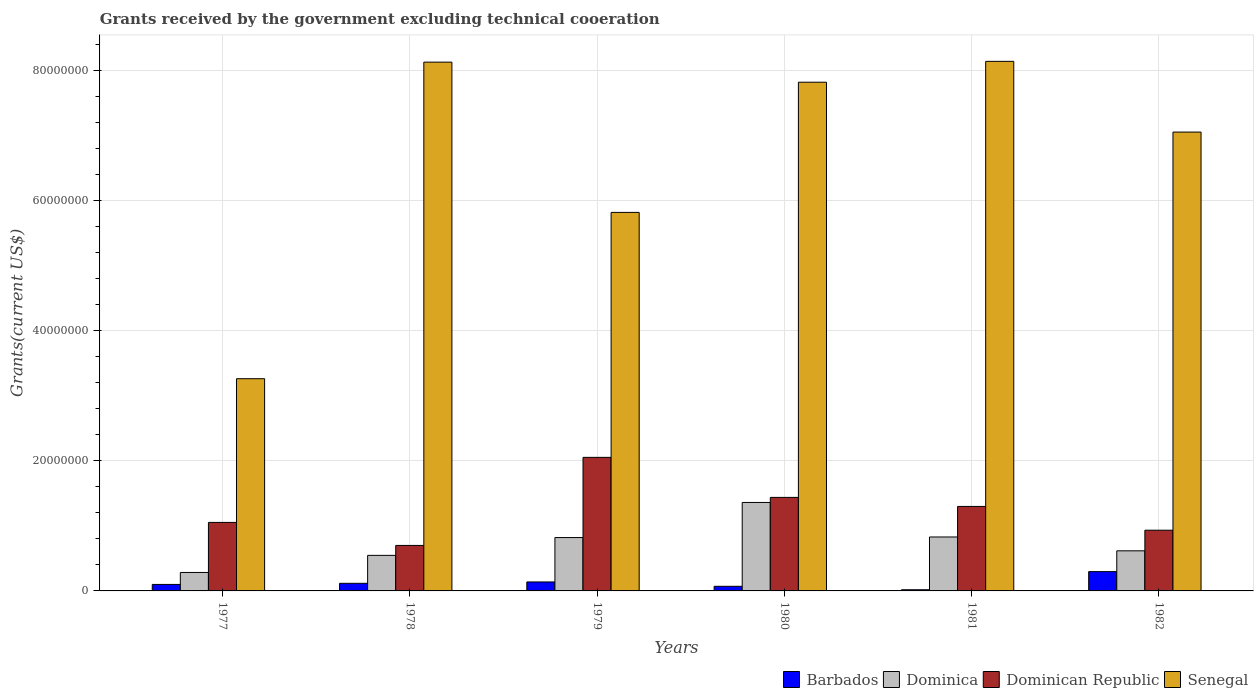How many different coloured bars are there?
Provide a succinct answer. 4. How many groups of bars are there?
Provide a succinct answer. 6. How many bars are there on the 4th tick from the left?
Ensure brevity in your answer.  4. How many bars are there on the 3rd tick from the right?
Give a very brief answer. 4. In how many cases, is the number of bars for a given year not equal to the number of legend labels?
Your response must be concise. 0. What is the total grants received by the government in Dominica in 1980?
Provide a succinct answer. 1.36e+07. Across all years, what is the maximum total grants received by the government in Dominican Republic?
Give a very brief answer. 2.06e+07. In which year was the total grants received by the government in Barbados maximum?
Give a very brief answer. 1982. In which year was the total grants received by the government in Barbados minimum?
Your answer should be compact. 1981. What is the total total grants received by the government in Dominican Republic in the graph?
Your response must be concise. 7.48e+07. What is the difference between the total grants received by the government in Senegal in 1979 and that in 1981?
Offer a terse response. -2.32e+07. What is the difference between the total grants received by the government in Senegal in 1981 and the total grants received by the government in Dominica in 1980?
Provide a succinct answer. 6.79e+07. What is the average total grants received by the government in Senegal per year?
Offer a terse response. 6.71e+07. In the year 1979, what is the difference between the total grants received by the government in Barbados and total grants received by the government in Senegal?
Provide a short and direct response. -5.69e+07. In how many years, is the total grants received by the government in Dominica greater than 20000000 US$?
Provide a short and direct response. 0. What is the ratio of the total grants received by the government in Dominican Republic in 1978 to that in 1981?
Offer a very short reply. 0.54. Is the difference between the total grants received by the government in Barbados in 1977 and 1981 greater than the difference between the total grants received by the government in Senegal in 1977 and 1981?
Keep it short and to the point. Yes. What is the difference between the highest and the lowest total grants received by the government in Senegal?
Give a very brief answer. 4.88e+07. Is it the case that in every year, the sum of the total grants received by the government in Dominica and total grants received by the government in Senegal is greater than the sum of total grants received by the government in Dominican Republic and total grants received by the government in Barbados?
Your answer should be compact. No. What does the 4th bar from the left in 1978 represents?
Give a very brief answer. Senegal. What does the 1st bar from the right in 1978 represents?
Your answer should be compact. Senegal. Is it the case that in every year, the sum of the total grants received by the government in Senegal and total grants received by the government in Dominican Republic is greater than the total grants received by the government in Dominica?
Keep it short and to the point. Yes. What is the difference between two consecutive major ticks on the Y-axis?
Ensure brevity in your answer.  2.00e+07. Are the values on the major ticks of Y-axis written in scientific E-notation?
Ensure brevity in your answer.  No. How many legend labels are there?
Ensure brevity in your answer.  4. What is the title of the graph?
Ensure brevity in your answer.  Grants received by the government excluding technical cooeration. What is the label or title of the X-axis?
Provide a succinct answer. Years. What is the label or title of the Y-axis?
Offer a terse response. Grants(current US$). What is the Grants(current US$) in Barbados in 1977?
Your response must be concise. 1.00e+06. What is the Grants(current US$) in Dominica in 1977?
Make the answer very short. 2.84e+06. What is the Grants(current US$) of Dominican Republic in 1977?
Give a very brief answer. 1.05e+07. What is the Grants(current US$) of Senegal in 1977?
Ensure brevity in your answer.  3.26e+07. What is the Grants(current US$) in Barbados in 1978?
Offer a very short reply. 1.17e+06. What is the Grants(current US$) in Dominica in 1978?
Offer a terse response. 5.47e+06. What is the Grants(current US$) in Senegal in 1978?
Keep it short and to the point. 8.14e+07. What is the Grants(current US$) in Barbados in 1979?
Keep it short and to the point. 1.38e+06. What is the Grants(current US$) in Dominica in 1979?
Offer a terse response. 8.21e+06. What is the Grants(current US$) in Dominican Republic in 1979?
Ensure brevity in your answer.  2.06e+07. What is the Grants(current US$) of Senegal in 1979?
Provide a short and direct response. 5.82e+07. What is the Grants(current US$) in Barbados in 1980?
Offer a very short reply. 7.10e+05. What is the Grants(current US$) in Dominica in 1980?
Your response must be concise. 1.36e+07. What is the Grants(current US$) in Dominican Republic in 1980?
Your answer should be compact. 1.44e+07. What is the Grants(current US$) of Senegal in 1980?
Offer a terse response. 7.83e+07. What is the Grants(current US$) in Barbados in 1981?
Offer a very short reply. 1.80e+05. What is the Grants(current US$) of Dominica in 1981?
Give a very brief answer. 8.30e+06. What is the Grants(current US$) in Dominican Republic in 1981?
Give a very brief answer. 1.30e+07. What is the Grants(current US$) of Senegal in 1981?
Keep it short and to the point. 8.15e+07. What is the Grants(current US$) in Barbados in 1982?
Ensure brevity in your answer.  2.97e+06. What is the Grants(current US$) in Dominica in 1982?
Your answer should be compact. 6.17e+06. What is the Grants(current US$) in Dominican Republic in 1982?
Offer a terse response. 9.34e+06. What is the Grants(current US$) of Senegal in 1982?
Your answer should be compact. 7.06e+07. Across all years, what is the maximum Grants(current US$) of Barbados?
Offer a very short reply. 2.97e+06. Across all years, what is the maximum Grants(current US$) of Dominica?
Your response must be concise. 1.36e+07. Across all years, what is the maximum Grants(current US$) in Dominican Republic?
Make the answer very short. 2.06e+07. Across all years, what is the maximum Grants(current US$) in Senegal?
Provide a short and direct response. 8.15e+07. Across all years, what is the minimum Grants(current US$) of Barbados?
Provide a short and direct response. 1.80e+05. Across all years, what is the minimum Grants(current US$) of Dominica?
Your answer should be compact. 2.84e+06. Across all years, what is the minimum Grants(current US$) of Senegal?
Give a very brief answer. 3.26e+07. What is the total Grants(current US$) in Barbados in the graph?
Provide a succinct answer. 7.41e+06. What is the total Grants(current US$) of Dominica in the graph?
Keep it short and to the point. 4.46e+07. What is the total Grants(current US$) of Dominican Republic in the graph?
Provide a succinct answer. 7.48e+07. What is the total Grants(current US$) of Senegal in the graph?
Your response must be concise. 4.03e+08. What is the difference between the Grants(current US$) in Barbados in 1977 and that in 1978?
Keep it short and to the point. -1.70e+05. What is the difference between the Grants(current US$) in Dominica in 1977 and that in 1978?
Your answer should be very brief. -2.63e+06. What is the difference between the Grants(current US$) in Dominican Republic in 1977 and that in 1978?
Give a very brief answer. 3.54e+06. What is the difference between the Grants(current US$) of Senegal in 1977 and that in 1978?
Your response must be concise. -4.87e+07. What is the difference between the Grants(current US$) of Barbados in 1977 and that in 1979?
Give a very brief answer. -3.80e+05. What is the difference between the Grants(current US$) of Dominica in 1977 and that in 1979?
Provide a succinct answer. -5.37e+06. What is the difference between the Grants(current US$) of Dominican Republic in 1977 and that in 1979?
Give a very brief answer. -1.00e+07. What is the difference between the Grants(current US$) in Senegal in 1977 and that in 1979?
Your response must be concise. -2.56e+07. What is the difference between the Grants(current US$) in Dominica in 1977 and that in 1980?
Provide a succinct answer. -1.08e+07. What is the difference between the Grants(current US$) in Dominican Republic in 1977 and that in 1980?
Your answer should be compact. -3.85e+06. What is the difference between the Grants(current US$) in Senegal in 1977 and that in 1980?
Make the answer very short. -4.56e+07. What is the difference between the Grants(current US$) of Barbados in 1977 and that in 1981?
Provide a succinct answer. 8.20e+05. What is the difference between the Grants(current US$) in Dominica in 1977 and that in 1981?
Provide a succinct answer. -5.46e+06. What is the difference between the Grants(current US$) of Dominican Republic in 1977 and that in 1981?
Ensure brevity in your answer.  -2.46e+06. What is the difference between the Grants(current US$) in Senegal in 1977 and that in 1981?
Ensure brevity in your answer.  -4.88e+07. What is the difference between the Grants(current US$) in Barbados in 1977 and that in 1982?
Offer a very short reply. -1.97e+06. What is the difference between the Grants(current US$) in Dominica in 1977 and that in 1982?
Your response must be concise. -3.33e+06. What is the difference between the Grants(current US$) of Dominican Republic in 1977 and that in 1982?
Your answer should be very brief. 1.20e+06. What is the difference between the Grants(current US$) of Senegal in 1977 and that in 1982?
Offer a terse response. -3.80e+07. What is the difference between the Grants(current US$) of Dominica in 1978 and that in 1979?
Give a very brief answer. -2.74e+06. What is the difference between the Grants(current US$) in Dominican Republic in 1978 and that in 1979?
Ensure brevity in your answer.  -1.36e+07. What is the difference between the Grants(current US$) in Senegal in 1978 and that in 1979?
Provide a succinct answer. 2.31e+07. What is the difference between the Grants(current US$) of Dominica in 1978 and that in 1980?
Provide a succinct answer. -8.14e+06. What is the difference between the Grants(current US$) of Dominican Republic in 1978 and that in 1980?
Your answer should be very brief. -7.39e+06. What is the difference between the Grants(current US$) of Senegal in 1978 and that in 1980?
Make the answer very short. 3.09e+06. What is the difference between the Grants(current US$) of Barbados in 1978 and that in 1981?
Ensure brevity in your answer.  9.90e+05. What is the difference between the Grants(current US$) of Dominica in 1978 and that in 1981?
Keep it short and to the point. -2.83e+06. What is the difference between the Grants(current US$) in Dominican Republic in 1978 and that in 1981?
Provide a succinct answer. -6.00e+06. What is the difference between the Grants(current US$) of Barbados in 1978 and that in 1982?
Keep it short and to the point. -1.80e+06. What is the difference between the Grants(current US$) in Dominica in 1978 and that in 1982?
Your response must be concise. -7.00e+05. What is the difference between the Grants(current US$) of Dominican Republic in 1978 and that in 1982?
Keep it short and to the point. -2.34e+06. What is the difference between the Grants(current US$) of Senegal in 1978 and that in 1982?
Provide a succinct answer. 1.08e+07. What is the difference between the Grants(current US$) of Barbados in 1979 and that in 1980?
Make the answer very short. 6.70e+05. What is the difference between the Grants(current US$) of Dominica in 1979 and that in 1980?
Offer a terse response. -5.40e+06. What is the difference between the Grants(current US$) of Dominican Republic in 1979 and that in 1980?
Make the answer very short. 6.16e+06. What is the difference between the Grants(current US$) of Senegal in 1979 and that in 1980?
Offer a very short reply. -2.00e+07. What is the difference between the Grants(current US$) of Barbados in 1979 and that in 1981?
Offer a terse response. 1.20e+06. What is the difference between the Grants(current US$) in Dominican Republic in 1979 and that in 1981?
Make the answer very short. 7.55e+06. What is the difference between the Grants(current US$) in Senegal in 1979 and that in 1981?
Ensure brevity in your answer.  -2.32e+07. What is the difference between the Grants(current US$) in Barbados in 1979 and that in 1982?
Give a very brief answer. -1.59e+06. What is the difference between the Grants(current US$) of Dominica in 1979 and that in 1982?
Give a very brief answer. 2.04e+06. What is the difference between the Grants(current US$) of Dominican Republic in 1979 and that in 1982?
Your answer should be very brief. 1.12e+07. What is the difference between the Grants(current US$) of Senegal in 1979 and that in 1982?
Provide a succinct answer. -1.24e+07. What is the difference between the Grants(current US$) in Barbados in 1980 and that in 1981?
Your answer should be compact. 5.30e+05. What is the difference between the Grants(current US$) in Dominica in 1980 and that in 1981?
Offer a very short reply. 5.31e+06. What is the difference between the Grants(current US$) in Dominican Republic in 1980 and that in 1981?
Make the answer very short. 1.39e+06. What is the difference between the Grants(current US$) of Senegal in 1980 and that in 1981?
Make the answer very short. -3.21e+06. What is the difference between the Grants(current US$) of Barbados in 1980 and that in 1982?
Your response must be concise. -2.26e+06. What is the difference between the Grants(current US$) in Dominica in 1980 and that in 1982?
Provide a short and direct response. 7.44e+06. What is the difference between the Grants(current US$) of Dominican Republic in 1980 and that in 1982?
Give a very brief answer. 5.05e+06. What is the difference between the Grants(current US$) of Senegal in 1980 and that in 1982?
Offer a very short reply. 7.67e+06. What is the difference between the Grants(current US$) of Barbados in 1981 and that in 1982?
Provide a short and direct response. -2.79e+06. What is the difference between the Grants(current US$) in Dominica in 1981 and that in 1982?
Your answer should be compact. 2.13e+06. What is the difference between the Grants(current US$) of Dominican Republic in 1981 and that in 1982?
Your answer should be compact. 3.66e+06. What is the difference between the Grants(current US$) of Senegal in 1981 and that in 1982?
Give a very brief answer. 1.09e+07. What is the difference between the Grants(current US$) in Barbados in 1977 and the Grants(current US$) in Dominica in 1978?
Keep it short and to the point. -4.47e+06. What is the difference between the Grants(current US$) in Barbados in 1977 and the Grants(current US$) in Dominican Republic in 1978?
Give a very brief answer. -6.00e+06. What is the difference between the Grants(current US$) in Barbados in 1977 and the Grants(current US$) in Senegal in 1978?
Offer a very short reply. -8.04e+07. What is the difference between the Grants(current US$) in Dominica in 1977 and the Grants(current US$) in Dominican Republic in 1978?
Your response must be concise. -4.16e+06. What is the difference between the Grants(current US$) in Dominica in 1977 and the Grants(current US$) in Senegal in 1978?
Ensure brevity in your answer.  -7.85e+07. What is the difference between the Grants(current US$) of Dominican Republic in 1977 and the Grants(current US$) of Senegal in 1978?
Your answer should be very brief. -7.08e+07. What is the difference between the Grants(current US$) in Barbados in 1977 and the Grants(current US$) in Dominica in 1979?
Ensure brevity in your answer.  -7.21e+06. What is the difference between the Grants(current US$) in Barbados in 1977 and the Grants(current US$) in Dominican Republic in 1979?
Make the answer very short. -1.96e+07. What is the difference between the Grants(current US$) in Barbados in 1977 and the Grants(current US$) in Senegal in 1979?
Ensure brevity in your answer.  -5.72e+07. What is the difference between the Grants(current US$) of Dominica in 1977 and the Grants(current US$) of Dominican Republic in 1979?
Offer a very short reply. -1.77e+07. What is the difference between the Grants(current US$) in Dominica in 1977 and the Grants(current US$) in Senegal in 1979?
Ensure brevity in your answer.  -5.54e+07. What is the difference between the Grants(current US$) of Dominican Republic in 1977 and the Grants(current US$) of Senegal in 1979?
Your answer should be compact. -4.77e+07. What is the difference between the Grants(current US$) in Barbados in 1977 and the Grants(current US$) in Dominica in 1980?
Your answer should be compact. -1.26e+07. What is the difference between the Grants(current US$) in Barbados in 1977 and the Grants(current US$) in Dominican Republic in 1980?
Provide a short and direct response. -1.34e+07. What is the difference between the Grants(current US$) of Barbados in 1977 and the Grants(current US$) of Senegal in 1980?
Your response must be concise. -7.73e+07. What is the difference between the Grants(current US$) of Dominica in 1977 and the Grants(current US$) of Dominican Republic in 1980?
Provide a succinct answer. -1.16e+07. What is the difference between the Grants(current US$) of Dominica in 1977 and the Grants(current US$) of Senegal in 1980?
Provide a short and direct response. -7.54e+07. What is the difference between the Grants(current US$) in Dominican Republic in 1977 and the Grants(current US$) in Senegal in 1980?
Give a very brief answer. -6.77e+07. What is the difference between the Grants(current US$) of Barbados in 1977 and the Grants(current US$) of Dominica in 1981?
Give a very brief answer. -7.30e+06. What is the difference between the Grants(current US$) in Barbados in 1977 and the Grants(current US$) in Dominican Republic in 1981?
Give a very brief answer. -1.20e+07. What is the difference between the Grants(current US$) in Barbados in 1977 and the Grants(current US$) in Senegal in 1981?
Offer a terse response. -8.05e+07. What is the difference between the Grants(current US$) of Dominica in 1977 and the Grants(current US$) of Dominican Republic in 1981?
Your response must be concise. -1.02e+07. What is the difference between the Grants(current US$) in Dominica in 1977 and the Grants(current US$) in Senegal in 1981?
Make the answer very short. -7.86e+07. What is the difference between the Grants(current US$) in Dominican Republic in 1977 and the Grants(current US$) in Senegal in 1981?
Offer a terse response. -7.09e+07. What is the difference between the Grants(current US$) in Barbados in 1977 and the Grants(current US$) in Dominica in 1982?
Your answer should be very brief. -5.17e+06. What is the difference between the Grants(current US$) of Barbados in 1977 and the Grants(current US$) of Dominican Republic in 1982?
Offer a terse response. -8.34e+06. What is the difference between the Grants(current US$) of Barbados in 1977 and the Grants(current US$) of Senegal in 1982?
Provide a short and direct response. -6.96e+07. What is the difference between the Grants(current US$) of Dominica in 1977 and the Grants(current US$) of Dominican Republic in 1982?
Provide a short and direct response. -6.50e+06. What is the difference between the Grants(current US$) in Dominica in 1977 and the Grants(current US$) in Senegal in 1982?
Keep it short and to the point. -6.78e+07. What is the difference between the Grants(current US$) of Dominican Republic in 1977 and the Grants(current US$) of Senegal in 1982?
Give a very brief answer. -6.01e+07. What is the difference between the Grants(current US$) in Barbados in 1978 and the Grants(current US$) in Dominica in 1979?
Offer a very short reply. -7.04e+06. What is the difference between the Grants(current US$) of Barbados in 1978 and the Grants(current US$) of Dominican Republic in 1979?
Give a very brief answer. -1.94e+07. What is the difference between the Grants(current US$) in Barbados in 1978 and the Grants(current US$) in Senegal in 1979?
Your response must be concise. -5.71e+07. What is the difference between the Grants(current US$) of Dominica in 1978 and the Grants(current US$) of Dominican Republic in 1979?
Your response must be concise. -1.51e+07. What is the difference between the Grants(current US$) of Dominica in 1978 and the Grants(current US$) of Senegal in 1979?
Ensure brevity in your answer.  -5.28e+07. What is the difference between the Grants(current US$) of Dominican Republic in 1978 and the Grants(current US$) of Senegal in 1979?
Provide a short and direct response. -5.12e+07. What is the difference between the Grants(current US$) of Barbados in 1978 and the Grants(current US$) of Dominica in 1980?
Ensure brevity in your answer.  -1.24e+07. What is the difference between the Grants(current US$) of Barbados in 1978 and the Grants(current US$) of Dominican Republic in 1980?
Offer a very short reply. -1.32e+07. What is the difference between the Grants(current US$) in Barbados in 1978 and the Grants(current US$) in Senegal in 1980?
Make the answer very short. -7.71e+07. What is the difference between the Grants(current US$) of Dominica in 1978 and the Grants(current US$) of Dominican Republic in 1980?
Provide a short and direct response. -8.92e+06. What is the difference between the Grants(current US$) of Dominica in 1978 and the Grants(current US$) of Senegal in 1980?
Keep it short and to the point. -7.28e+07. What is the difference between the Grants(current US$) of Dominican Republic in 1978 and the Grants(current US$) of Senegal in 1980?
Make the answer very short. -7.13e+07. What is the difference between the Grants(current US$) of Barbados in 1978 and the Grants(current US$) of Dominica in 1981?
Give a very brief answer. -7.13e+06. What is the difference between the Grants(current US$) in Barbados in 1978 and the Grants(current US$) in Dominican Republic in 1981?
Your answer should be compact. -1.18e+07. What is the difference between the Grants(current US$) of Barbados in 1978 and the Grants(current US$) of Senegal in 1981?
Give a very brief answer. -8.03e+07. What is the difference between the Grants(current US$) in Dominica in 1978 and the Grants(current US$) in Dominican Republic in 1981?
Ensure brevity in your answer.  -7.53e+06. What is the difference between the Grants(current US$) of Dominica in 1978 and the Grants(current US$) of Senegal in 1981?
Keep it short and to the point. -7.60e+07. What is the difference between the Grants(current US$) in Dominican Republic in 1978 and the Grants(current US$) in Senegal in 1981?
Your answer should be very brief. -7.45e+07. What is the difference between the Grants(current US$) in Barbados in 1978 and the Grants(current US$) in Dominica in 1982?
Your response must be concise. -5.00e+06. What is the difference between the Grants(current US$) in Barbados in 1978 and the Grants(current US$) in Dominican Republic in 1982?
Provide a succinct answer. -8.17e+06. What is the difference between the Grants(current US$) of Barbados in 1978 and the Grants(current US$) of Senegal in 1982?
Provide a succinct answer. -6.94e+07. What is the difference between the Grants(current US$) of Dominica in 1978 and the Grants(current US$) of Dominican Republic in 1982?
Your answer should be compact. -3.87e+06. What is the difference between the Grants(current US$) in Dominica in 1978 and the Grants(current US$) in Senegal in 1982?
Provide a short and direct response. -6.51e+07. What is the difference between the Grants(current US$) of Dominican Republic in 1978 and the Grants(current US$) of Senegal in 1982?
Make the answer very short. -6.36e+07. What is the difference between the Grants(current US$) in Barbados in 1979 and the Grants(current US$) in Dominica in 1980?
Your response must be concise. -1.22e+07. What is the difference between the Grants(current US$) in Barbados in 1979 and the Grants(current US$) in Dominican Republic in 1980?
Offer a terse response. -1.30e+07. What is the difference between the Grants(current US$) in Barbados in 1979 and the Grants(current US$) in Senegal in 1980?
Offer a very short reply. -7.69e+07. What is the difference between the Grants(current US$) of Dominica in 1979 and the Grants(current US$) of Dominican Republic in 1980?
Offer a terse response. -6.18e+06. What is the difference between the Grants(current US$) in Dominica in 1979 and the Grants(current US$) in Senegal in 1980?
Your answer should be very brief. -7.01e+07. What is the difference between the Grants(current US$) of Dominican Republic in 1979 and the Grants(current US$) of Senegal in 1980?
Offer a very short reply. -5.77e+07. What is the difference between the Grants(current US$) in Barbados in 1979 and the Grants(current US$) in Dominica in 1981?
Your answer should be compact. -6.92e+06. What is the difference between the Grants(current US$) in Barbados in 1979 and the Grants(current US$) in Dominican Republic in 1981?
Keep it short and to the point. -1.16e+07. What is the difference between the Grants(current US$) of Barbados in 1979 and the Grants(current US$) of Senegal in 1981?
Provide a succinct answer. -8.01e+07. What is the difference between the Grants(current US$) of Dominica in 1979 and the Grants(current US$) of Dominican Republic in 1981?
Your answer should be very brief. -4.79e+06. What is the difference between the Grants(current US$) of Dominica in 1979 and the Grants(current US$) of Senegal in 1981?
Make the answer very short. -7.33e+07. What is the difference between the Grants(current US$) in Dominican Republic in 1979 and the Grants(current US$) in Senegal in 1981?
Provide a short and direct response. -6.09e+07. What is the difference between the Grants(current US$) of Barbados in 1979 and the Grants(current US$) of Dominica in 1982?
Offer a terse response. -4.79e+06. What is the difference between the Grants(current US$) in Barbados in 1979 and the Grants(current US$) in Dominican Republic in 1982?
Make the answer very short. -7.96e+06. What is the difference between the Grants(current US$) of Barbados in 1979 and the Grants(current US$) of Senegal in 1982?
Provide a short and direct response. -6.92e+07. What is the difference between the Grants(current US$) of Dominica in 1979 and the Grants(current US$) of Dominican Republic in 1982?
Provide a succinct answer. -1.13e+06. What is the difference between the Grants(current US$) in Dominica in 1979 and the Grants(current US$) in Senegal in 1982?
Your answer should be compact. -6.24e+07. What is the difference between the Grants(current US$) of Dominican Republic in 1979 and the Grants(current US$) of Senegal in 1982?
Your answer should be compact. -5.00e+07. What is the difference between the Grants(current US$) of Barbados in 1980 and the Grants(current US$) of Dominica in 1981?
Offer a very short reply. -7.59e+06. What is the difference between the Grants(current US$) in Barbados in 1980 and the Grants(current US$) in Dominican Republic in 1981?
Offer a terse response. -1.23e+07. What is the difference between the Grants(current US$) in Barbados in 1980 and the Grants(current US$) in Senegal in 1981?
Ensure brevity in your answer.  -8.08e+07. What is the difference between the Grants(current US$) in Dominica in 1980 and the Grants(current US$) in Senegal in 1981?
Offer a very short reply. -6.79e+07. What is the difference between the Grants(current US$) in Dominican Republic in 1980 and the Grants(current US$) in Senegal in 1981?
Make the answer very short. -6.71e+07. What is the difference between the Grants(current US$) of Barbados in 1980 and the Grants(current US$) of Dominica in 1982?
Offer a terse response. -5.46e+06. What is the difference between the Grants(current US$) in Barbados in 1980 and the Grants(current US$) in Dominican Republic in 1982?
Provide a short and direct response. -8.63e+06. What is the difference between the Grants(current US$) in Barbados in 1980 and the Grants(current US$) in Senegal in 1982?
Your response must be concise. -6.99e+07. What is the difference between the Grants(current US$) in Dominica in 1980 and the Grants(current US$) in Dominican Republic in 1982?
Offer a very short reply. 4.27e+06. What is the difference between the Grants(current US$) in Dominica in 1980 and the Grants(current US$) in Senegal in 1982?
Your answer should be compact. -5.70e+07. What is the difference between the Grants(current US$) of Dominican Republic in 1980 and the Grants(current US$) of Senegal in 1982?
Your response must be concise. -5.62e+07. What is the difference between the Grants(current US$) of Barbados in 1981 and the Grants(current US$) of Dominica in 1982?
Provide a short and direct response. -5.99e+06. What is the difference between the Grants(current US$) of Barbados in 1981 and the Grants(current US$) of Dominican Republic in 1982?
Your answer should be compact. -9.16e+06. What is the difference between the Grants(current US$) in Barbados in 1981 and the Grants(current US$) in Senegal in 1982?
Offer a terse response. -7.04e+07. What is the difference between the Grants(current US$) in Dominica in 1981 and the Grants(current US$) in Dominican Republic in 1982?
Ensure brevity in your answer.  -1.04e+06. What is the difference between the Grants(current US$) of Dominica in 1981 and the Grants(current US$) of Senegal in 1982?
Provide a short and direct response. -6.23e+07. What is the difference between the Grants(current US$) of Dominican Republic in 1981 and the Grants(current US$) of Senegal in 1982?
Give a very brief answer. -5.76e+07. What is the average Grants(current US$) in Barbados per year?
Provide a succinct answer. 1.24e+06. What is the average Grants(current US$) of Dominica per year?
Give a very brief answer. 7.43e+06. What is the average Grants(current US$) in Dominican Republic per year?
Keep it short and to the point. 1.25e+07. What is the average Grants(current US$) of Senegal per year?
Give a very brief answer. 6.71e+07. In the year 1977, what is the difference between the Grants(current US$) in Barbados and Grants(current US$) in Dominica?
Your answer should be compact. -1.84e+06. In the year 1977, what is the difference between the Grants(current US$) in Barbados and Grants(current US$) in Dominican Republic?
Keep it short and to the point. -9.54e+06. In the year 1977, what is the difference between the Grants(current US$) in Barbados and Grants(current US$) in Senegal?
Your answer should be very brief. -3.16e+07. In the year 1977, what is the difference between the Grants(current US$) in Dominica and Grants(current US$) in Dominican Republic?
Make the answer very short. -7.70e+06. In the year 1977, what is the difference between the Grants(current US$) in Dominica and Grants(current US$) in Senegal?
Make the answer very short. -2.98e+07. In the year 1977, what is the difference between the Grants(current US$) in Dominican Republic and Grants(current US$) in Senegal?
Offer a very short reply. -2.21e+07. In the year 1978, what is the difference between the Grants(current US$) in Barbados and Grants(current US$) in Dominica?
Offer a terse response. -4.30e+06. In the year 1978, what is the difference between the Grants(current US$) in Barbados and Grants(current US$) in Dominican Republic?
Keep it short and to the point. -5.83e+06. In the year 1978, what is the difference between the Grants(current US$) in Barbados and Grants(current US$) in Senegal?
Provide a succinct answer. -8.02e+07. In the year 1978, what is the difference between the Grants(current US$) in Dominica and Grants(current US$) in Dominican Republic?
Keep it short and to the point. -1.53e+06. In the year 1978, what is the difference between the Grants(current US$) in Dominica and Grants(current US$) in Senegal?
Your answer should be compact. -7.59e+07. In the year 1978, what is the difference between the Grants(current US$) of Dominican Republic and Grants(current US$) of Senegal?
Provide a short and direct response. -7.44e+07. In the year 1979, what is the difference between the Grants(current US$) of Barbados and Grants(current US$) of Dominica?
Offer a terse response. -6.83e+06. In the year 1979, what is the difference between the Grants(current US$) in Barbados and Grants(current US$) in Dominican Republic?
Offer a very short reply. -1.92e+07. In the year 1979, what is the difference between the Grants(current US$) in Barbados and Grants(current US$) in Senegal?
Provide a short and direct response. -5.69e+07. In the year 1979, what is the difference between the Grants(current US$) in Dominica and Grants(current US$) in Dominican Republic?
Offer a very short reply. -1.23e+07. In the year 1979, what is the difference between the Grants(current US$) of Dominica and Grants(current US$) of Senegal?
Ensure brevity in your answer.  -5.00e+07. In the year 1979, what is the difference between the Grants(current US$) of Dominican Republic and Grants(current US$) of Senegal?
Your answer should be compact. -3.77e+07. In the year 1980, what is the difference between the Grants(current US$) in Barbados and Grants(current US$) in Dominica?
Ensure brevity in your answer.  -1.29e+07. In the year 1980, what is the difference between the Grants(current US$) of Barbados and Grants(current US$) of Dominican Republic?
Keep it short and to the point. -1.37e+07. In the year 1980, what is the difference between the Grants(current US$) in Barbados and Grants(current US$) in Senegal?
Your response must be concise. -7.76e+07. In the year 1980, what is the difference between the Grants(current US$) in Dominica and Grants(current US$) in Dominican Republic?
Make the answer very short. -7.80e+05. In the year 1980, what is the difference between the Grants(current US$) of Dominica and Grants(current US$) of Senegal?
Offer a terse response. -6.47e+07. In the year 1980, what is the difference between the Grants(current US$) of Dominican Republic and Grants(current US$) of Senegal?
Your answer should be very brief. -6.39e+07. In the year 1981, what is the difference between the Grants(current US$) in Barbados and Grants(current US$) in Dominica?
Offer a terse response. -8.12e+06. In the year 1981, what is the difference between the Grants(current US$) in Barbados and Grants(current US$) in Dominican Republic?
Ensure brevity in your answer.  -1.28e+07. In the year 1981, what is the difference between the Grants(current US$) of Barbados and Grants(current US$) of Senegal?
Make the answer very short. -8.13e+07. In the year 1981, what is the difference between the Grants(current US$) of Dominica and Grants(current US$) of Dominican Republic?
Provide a short and direct response. -4.70e+06. In the year 1981, what is the difference between the Grants(current US$) of Dominica and Grants(current US$) of Senegal?
Keep it short and to the point. -7.32e+07. In the year 1981, what is the difference between the Grants(current US$) in Dominican Republic and Grants(current US$) in Senegal?
Your answer should be very brief. -6.85e+07. In the year 1982, what is the difference between the Grants(current US$) in Barbados and Grants(current US$) in Dominica?
Make the answer very short. -3.20e+06. In the year 1982, what is the difference between the Grants(current US$) in Barbados and Grants(current US$) in Dominican Republic?
Offer a terse response. -6.37e+06. In the year 1982, what is the difference between the Grants(current US$) in Barbados and Grants(current US$) in Senegal?
Make the answer very short. -6.76e+07. In the year 1982, what is the difference between the Grants(current US$) of Dominica and Grants(current US$) of Dominican Republic?
Make the answer very short. -3.17e+06. In the year 1982, what is the difference between the Grants(current US$) of Dominica and Grants(current US$) of Senegal?
Your answer should be very brief. -6.44e+07. In the year 1982, what is the difference between the Grants(current US$) in Dominican Republic and Grants(current US$) in Senegal?
Offer a terse response. -6.13e+07. What is the ratio of the Grants(current US$) of Barbados in 1977 to that in 1978?
Ensure brevity in your answer.  0.85. What is the ratio of the Grants(current US$) of Dominica in 1977 to that in 1978?
Provide a short and direct response. 0.52. What is the ratio of the Grants(current US$) of Dominican Republic in 1977 to that in 1978?
Offer a terse response. 1.51. What is the ratio of the Grants(current US$) of Senegal in 1977 to that in 1978?
Your response must be concise. 0.4. What is the ratio of the Grants(current US$) in Barbados in 1977 to that in 1979?
Provide a succinct answer. 0.72. What is the ratio of the Grants(current US$) in Dominica in 1977 to that in 1979?
Your answer should be very brief. 0.35. What is the ratio of the Grants(current US$) in Dominican Republic in 1977 to that in 1979?
Ensure brevity in your answer.  0.51. What is the ratio of the Grants(current US$) in Senegal in 1977 to that in 1979?
Provide a short and direct response. 0.56. What is the ratio of the Grants(current US$) in Barbados in 1977 to that in 1980?
Give a very brief answer. 1.41. What is the ratio of the Grants(current US$) in Dominica in 1977 to that in 1980?
Provide a short and direct response. 0.21. What is the ratio of the Grants(current US$) of Dominican Republic in 1977 to that in 1980?
Offer a terse response. 0.73. What is the ratio of the Grants(current US$) of Senegal in 1977 to that in 1980?
Give a very brief answer. 0.42. What is the ratio of the Grants(current US$) in Barbados in 1977 to that in 1981?
Your response must be concise. 5.56. What is the ratio of the Grants(current US$) of Dominica in 1977 to that in 1981?
Provide a succinct answer. 0.34. What is the ratio of the Grants(current US$) in Dominican Republic in 1977 to that in 1981?
Give a very brief answer. 0.81. What is the ratio of the Grants(current US$) of Senegal in 1977 to that in 1981?
Keep it short and to the point. 0.4. What is the ratio of the Grants(current US$) in Barbados in 1977 to that in 1982?
Your answer should be very brief. 0.34. What is the ratio of the Grants(current US$) of Dominica in 1977 to that in 1982?
Offer a terse response. 0.46. What is the ratio of the Grants(current US$) of Dominican Republic in 1977 to that in 1982?
Your response must be concise. 1.13. What is the ratio of the Grants(current US$) of Senegal in 1977 to that in 1982?
Your answer should be very brief. 0.46. What is the ratio of the Grants(current US$) in Barbados in 1978 to that in 1979?
Provide a short and direct response. 0.85. What is the ratio of the Grants(current US$) of Dominica in 1978 to that in 1979?
Give a very brief answer. 0.67. What is the ratio of the Grants(current US$) in Dominican Republic in 1978 to that in 1979?
Ensure brevity in your answer.  0.34. What is the ratio of the Grants(current US$) of Senegal in 1978 to that in 1979?
Offer a very short reply. 1.4. What is the ratio of the Grants(current US$) in Barbados in 1978 to that in 1980?
Ensure brevity in your answer.  1.65. What is the ratio of the Grants(current US$) in Dominica in 1978 to that in 1980?
Provide a succinct answer. 0.4. What is the ratio of the Grants(current US$) of Dominican Republic in 1978 to that in 1980?
Your answer should be very brief. 0.49. What is the ratio of the Grants(current US$) in Senegal in 1978 to that in 1980?
Your answer should be very brief. 1.04. What is the ratio of the Grants(current US$) in Dominica in 1978 to that in 1981?
Provide a short and direct response. 0.66. What is the ratio of the Grants(current US$) in Dominican Republic in 1978 to that in 1981?
Offer a very short reply. 0.54. What is the ratio of the Grants(current US$) of Senegal in 1978 to that in 1981?
Your response must be concise. 1. What is the ratio of the Grants(current US$) in Barbados in 1978 to that in 1982?
Ensure brevity in your answer.  0.39. What is the ratio of the Grants(current US$) in Dominica in 1978 to that in 1982?
Provide a succinct answer. 0.89. What is the ratio of the Grants(current US$) in Dominican Republic in 1978 to that in 1982?
Give a very brief answer. 0.75. What is the ratio of the Grants(current US$) of Senegal in 1978 to that in 1982?
Offer a very short reply. 1.15. What is the ratio of the Grants(current US$) in Barbados in 1979 to that in 1980?
Your response must be concise. 1.94. What is the ratio of the Grants(current US$) of Dominica in 1979 to that in 1980?
Give a very brief answer. 0.6. What is the ratio of the Grants(current US$) in Dominican Republic in 1979 to that in 1980?
Your response must be concise. 1.43. What is the ratio of the Grants(current US$) in Senegal in 1979 to that in 1980?
Give a very brief answer. 0.74. What is the ratio of the Grants(current US$) of Barbados in 1979 to that in 1981?
Ensure brevity in your answer.  7.67. What is the ratio of the Grants(current US$) in Dominican Republic in 1979 to that in 1981?
Provide a short and direct response. 1.58. What is the ratio of the Grants(current US$) of Senegal in 1979 to that in 1981?
Provide a short and direct response. 0.71. What is the ratio of the Grants(current US$) of Barbados in 1979 to that in 1982?
Keep it short and to the point. 0.46. What is the ratio of the Grants(current US$) in Dominica in 1979 to that in 1982?
Provide a short and direct response. 1.33. What is the ratio of the Grants(current US$) in Dominican Republic in 1979 to that in 1982?
Offer a very short reply. 2.2. What is the ratio of the Grants(current US$) of Senegal in 1979 to that in 1982?
Your answer should be very brief. 0.82. What is the ratio of the Grants(current US$) in Barbados in 1980 to that in 1981?
Your response must be concise. 3.94. What is the ratio of the Grants(current US$) in Dominica in 1980 to that in 1981?
Your answer should be compact. 1.64. What is the ratio of the Grants(current US$) of Dominican Republic in 1980 to that in 1981?
Provide a succinct answer. 1.11. What is the ratio of the Grants(current US$) in Senegal in 1980 to that in 1981?
Your answer should be compact. 0.96. What is the ratio of the Grants(current US$) of Barbados in 1980 to that in 1982?
Ensure brevity in your answer.  0.24. What is the ratio of the Grants(current US$) of Dominica in 1980 to that in 1982?
Give a very brief answer. 2.21. What is the ratio of the Grants(current US$) in Dominican Republic in 1980 to that in 1982?
Give a very brief answer. 1.54. What is the ratio of the Grants(current US$) in Senegal in 1980 to that in 1982?
Offer a terse response. 1.11. What is the ratio of the Grants(current US$) of Barbados in 1981 to that in 1982?
Keep it short and to the point. 0.06. What is the ratio of the Grants(current US$) of Dominica in 1981 to that in 1982?
Your answer should be compact. 1.35. What is the ratio of the Grants(current US$) in Dominican Republic in 1981 to that in 1982?
Offer a terse response. 1.39. What is the ratio of the Grants(current US$) of Senegal in 1981 to that in 1982?
Give a very brief answer. 1.15. What is the difference between the highest and the second highest Grants(current US$) of Barbados?
Your response must be concise. 1.59e+06. What is the difference between the highest and the second highest Grants(current US$) in Dominica?
Offer a very short reply. 5.31e+06. What is the difference between the highest and the second highest Grants(current US$) of Dominican Republic?
Offer a very short reply. 6.16e+06. What is the difference between the highest and the lowest Grants(current US$) in Barbados?
Your response must be concise. 2.79e+06. What is the difference between the highest and the lowest Grants(current US$) in Dominica?
Your answer should be compact. 1.08e+07. What is the difference between the highest and the lowest Grants(current US$) of Dominican Republic?
Offer a very short reply. 1.36e+07. What is the difference between the highest and the lowest Grants(current US$) in Senegal?
Ensure brevity in your answer.  4.88e+07. 